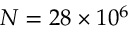Convert formula to latex. <formula><loc_0><loc_0><loc_500><loc_500>N = 2 8 \times 1 0 ^ { 6 }</formula> 